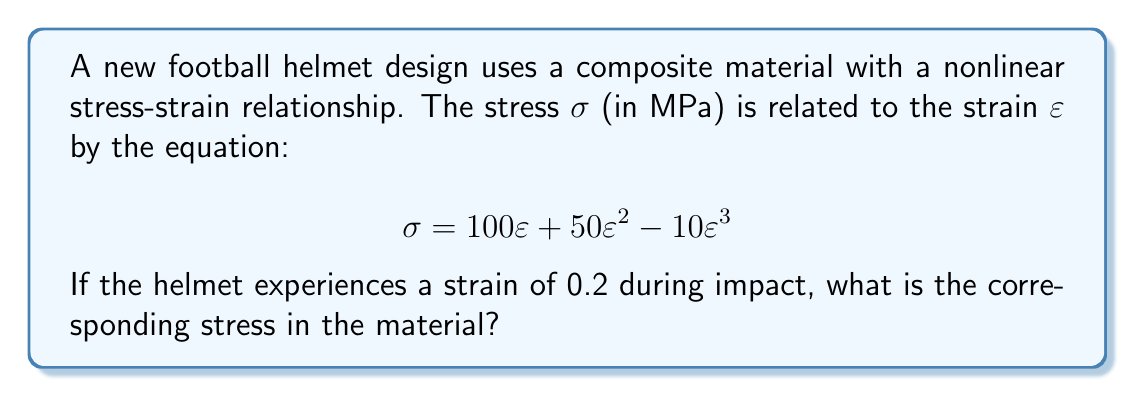Show me your answer to this math problem. To solve this problem, we need to follow these steps:

1) We are given the nonlinear stress-strain relationship:
   $$\sigma = 100\varepsilon + 50\varepsilon^2 - 10\varepsilon^3$$

2) We know that the strain $\varepsilon = 0.2$

3) Let's substitute $\varepsilon = 0.2$ into the equation:
   $$\sigma = 100(0.2) + 50(0.2)^2 - 10(0.2)^3$$

4) Now, let's calculate each term:
   - First term: $100(0.2) = 20$
   - Second term: $50(0.2)^2 = 50(0.04) = 2$
   - Third term: $-10(0.2)^3 = -10(0.008) = -0.08$

5) Sum up all the terms:
   $$\sigma = 20 + 2 - 0.08 = 21.92$$

Therefore, the stress in the material when the strain is 0.2 is 21.92 MPa.
Answer: 21.92 MPa 